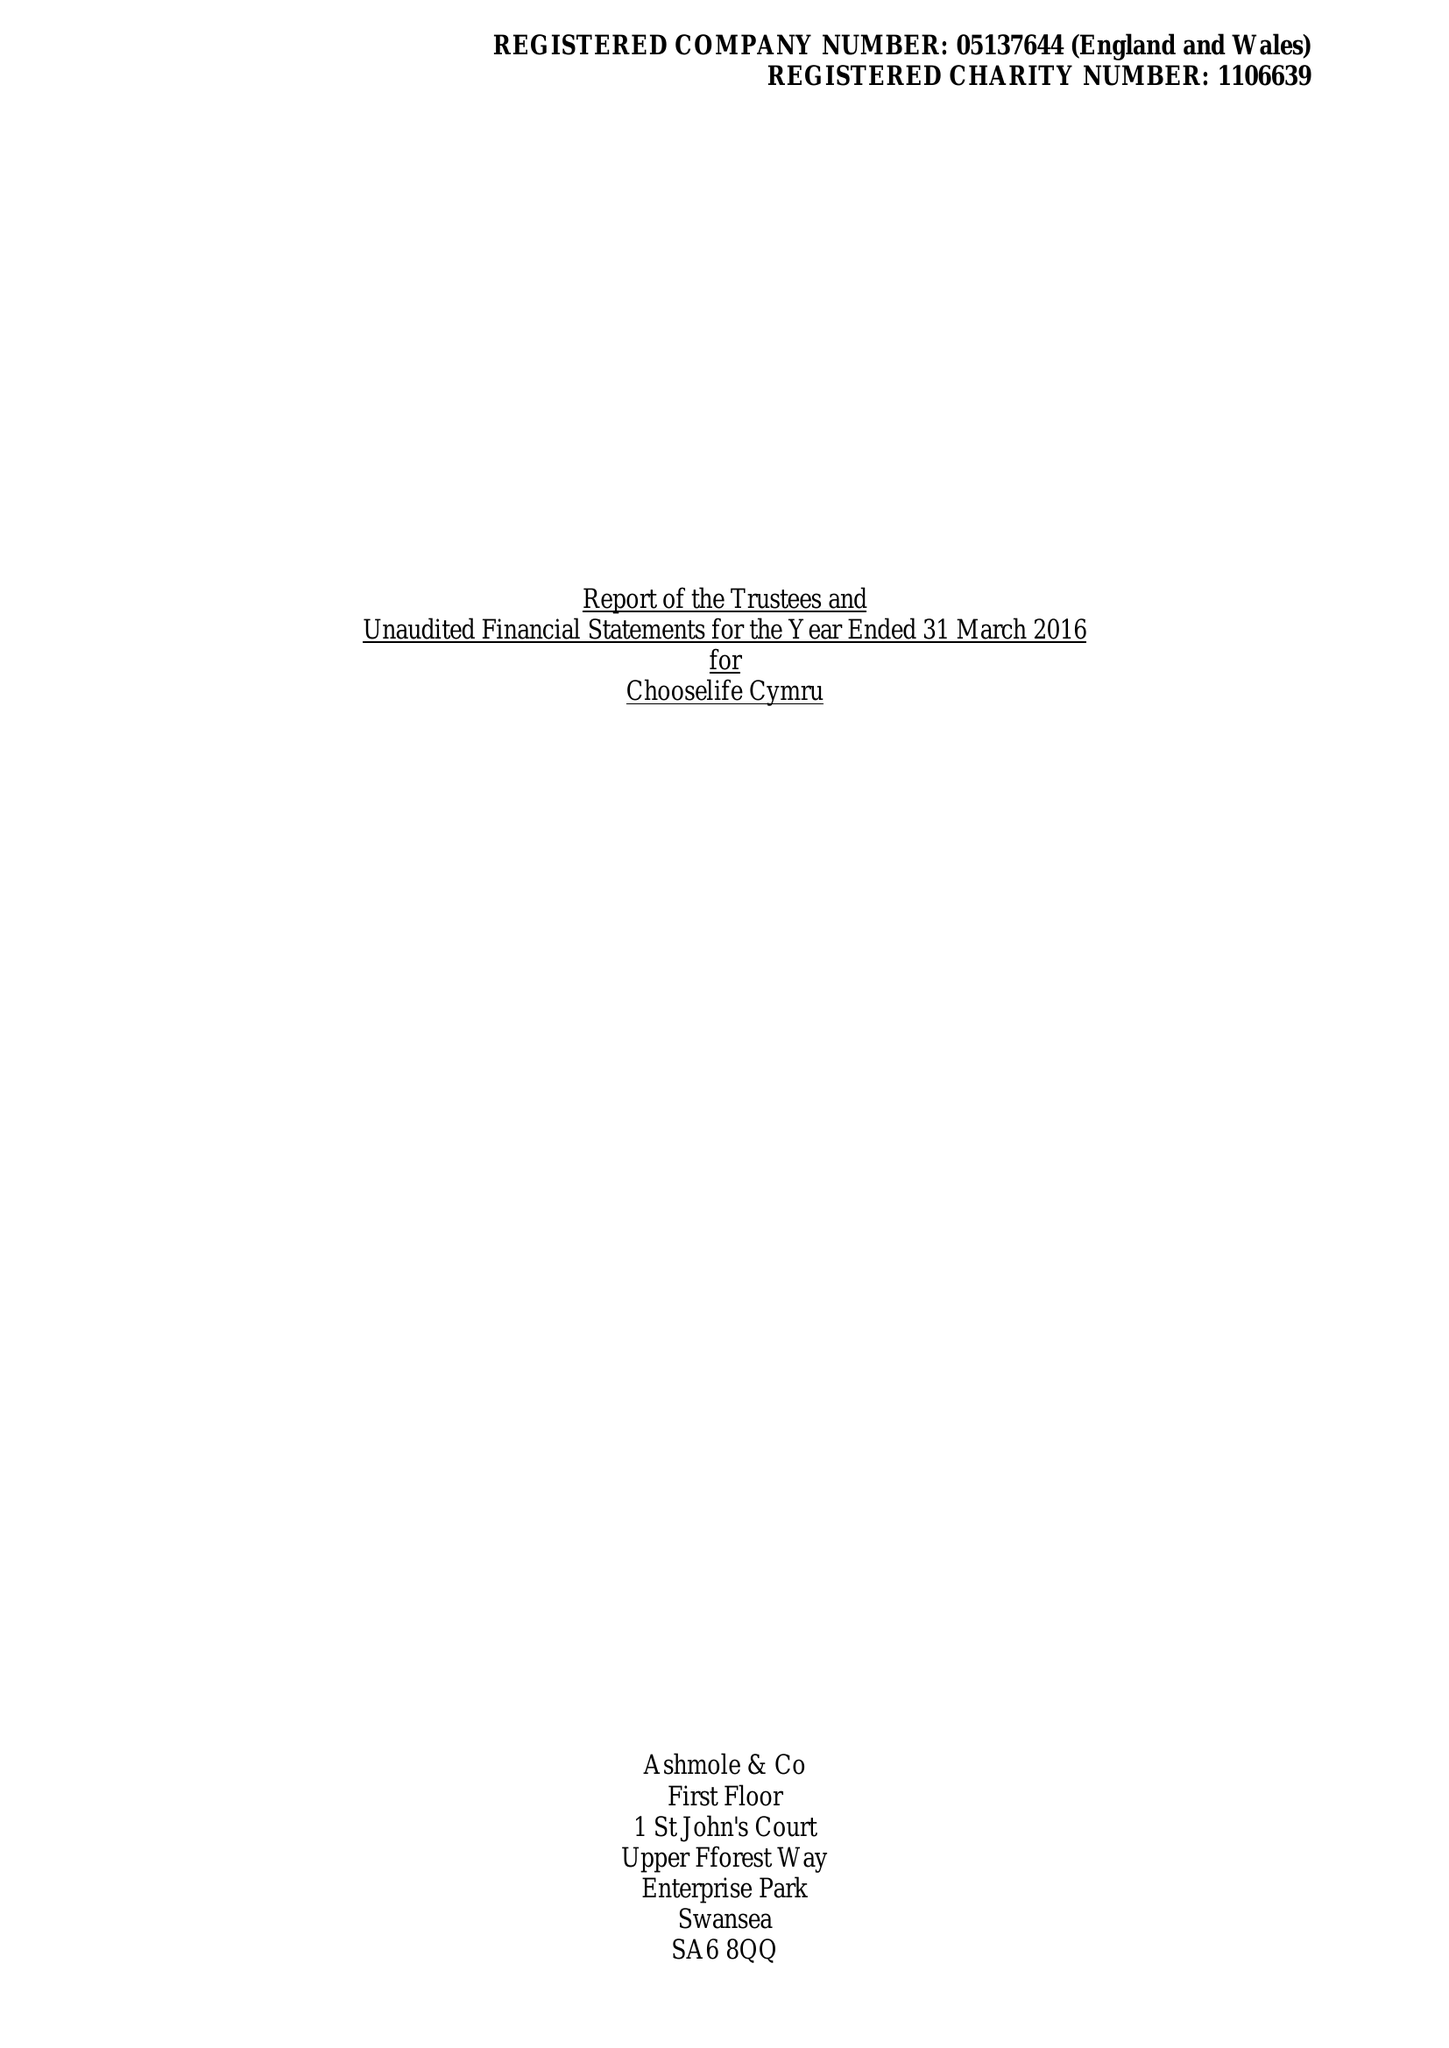What is the value for the address__street_line?
Answer the question using a single word or phrase. None 